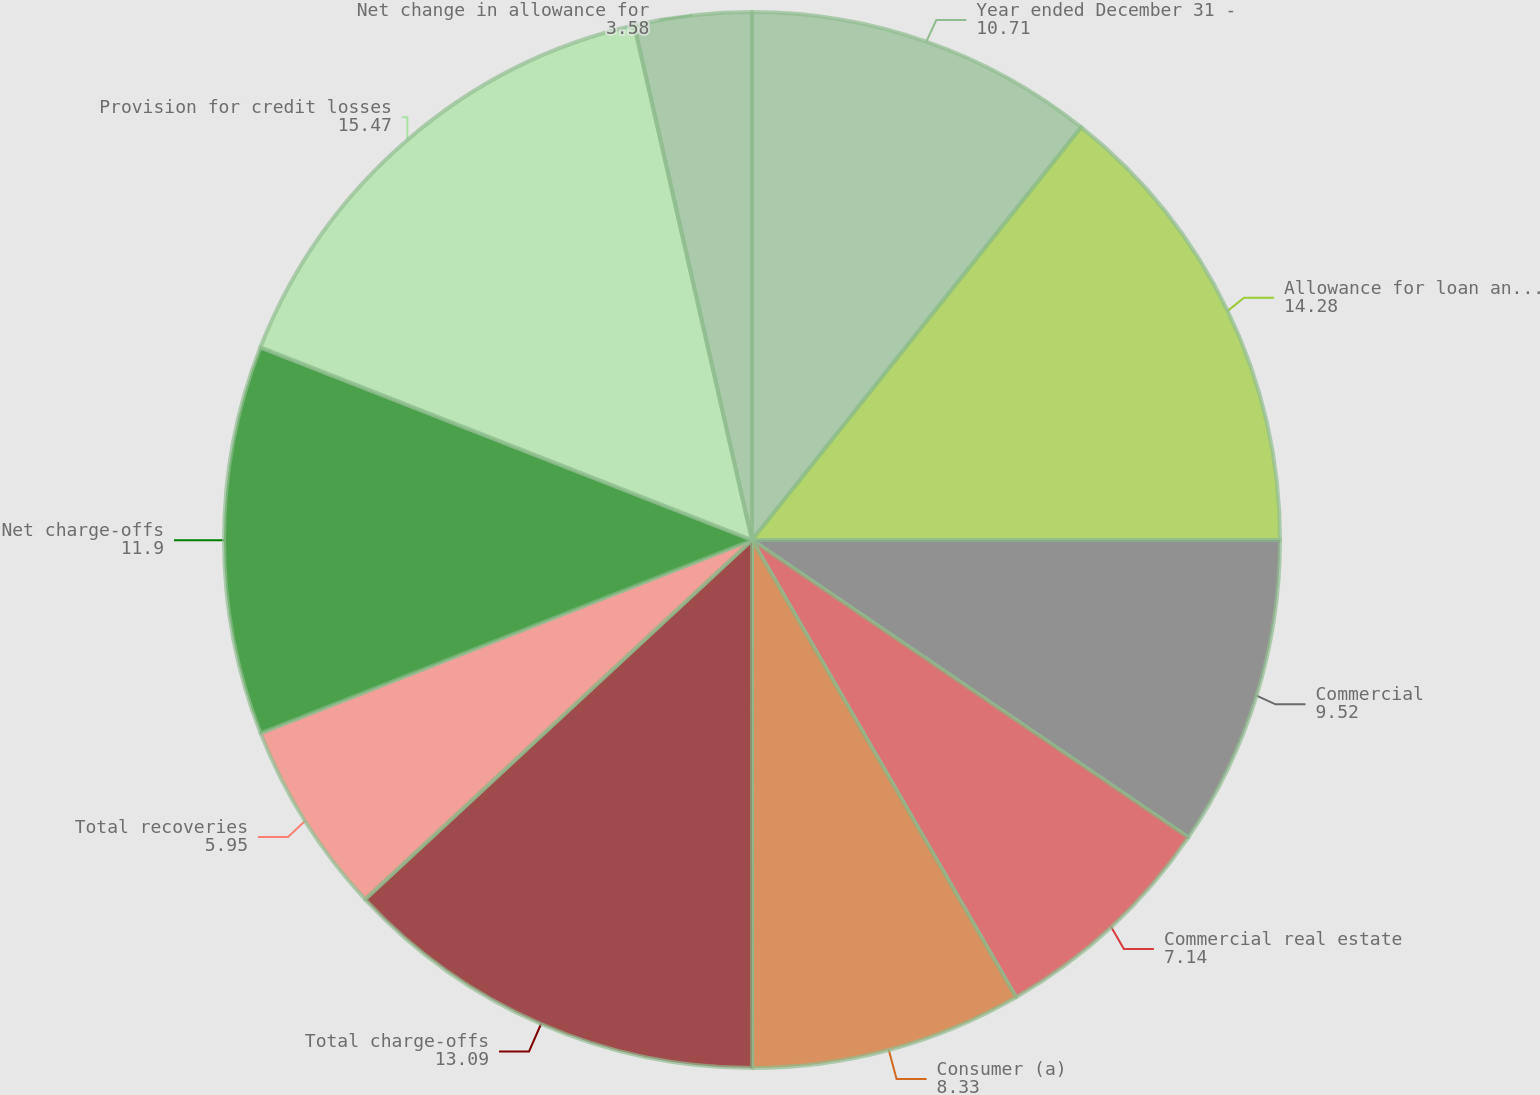Convert chart to OTSL. <chart><loc_0><loc_0><loc_500><loc_500><pie_chart><fcel>Year ended December 31 -<fcel>Allowance for loan and lease<fcel>Commercial<fcel>Commercial real estate<fcel>Consumer (a)<fcel>Total charge-offs<fcel>Total recoveries<fcel>Net charge-offs<fcel>Provision for credit losses<fcel>Net change in allowance for<nl><fcel>10.71%<fcel>14.28%<fcel>9.52%<fcel>7.14%<fcel>8.33%<fcel>13.09%<fcel>5.95%<fcel>11.9%<fcel>15.47%<fcel>3.58%<nl></chart> 